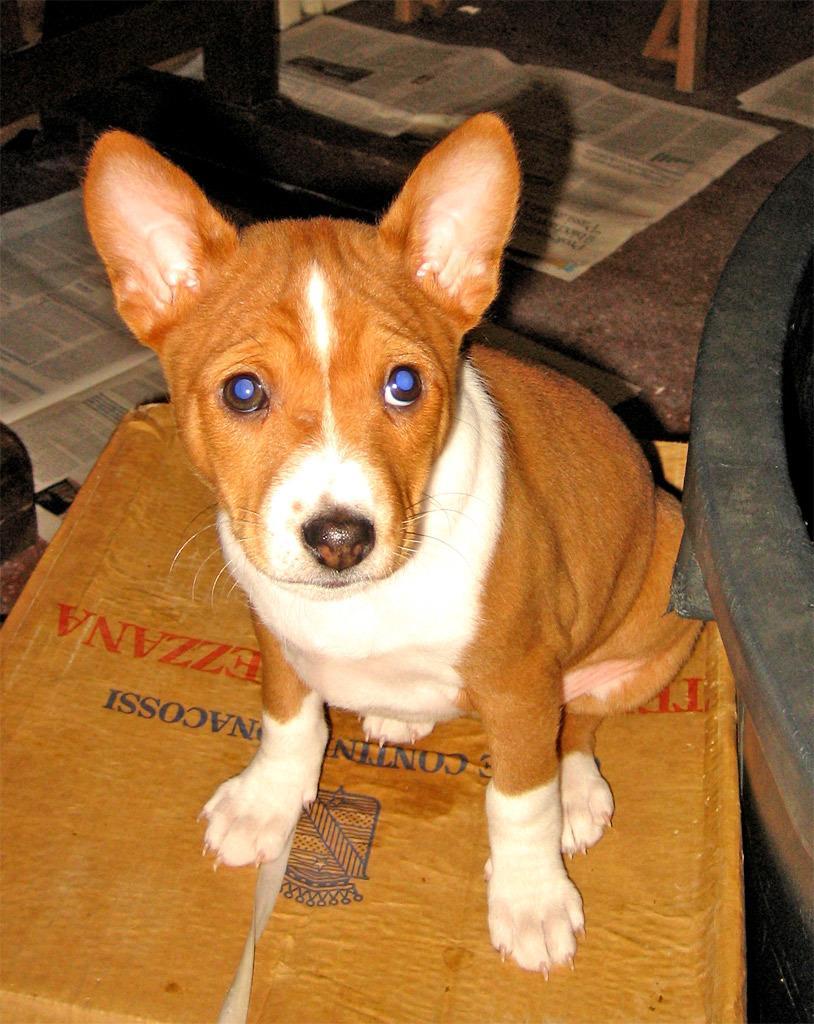Can you describe this image briefly? We can see a dog in the image with blue eye ball and the papers are surrounded by a dog. 